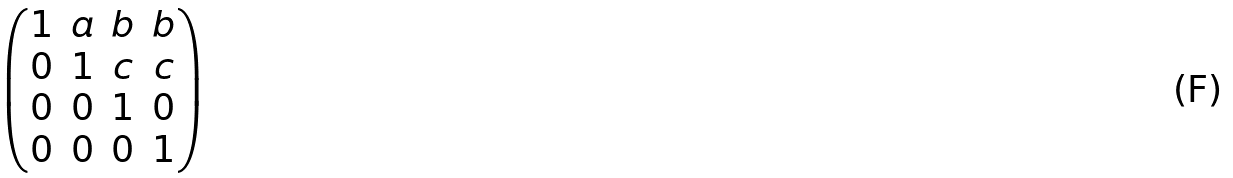Convert formula to latex. <formula><loc_0><loc_0><loc_500><loc_500>\begin{pmatrix} 1 & a & b & b \\ 0 & 1 & c & c \\ 0 & 0 & 1 & 0 \\ 0 & 0 & 0 & 1 \end{pmatrix}</formula> 